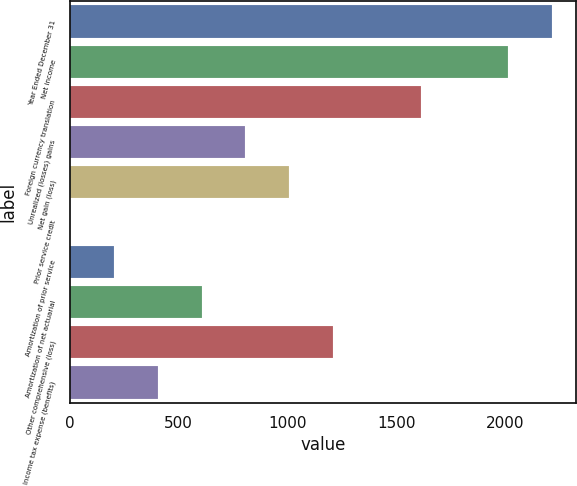Convert chart to OTSL. <chart><loc_0><loc_0><loc_500><loc_500><bar_chart><fcel>Year Ended December 31<fcel>Net income<fcel>Foreign currency translation<fcel>Unrealized (losses) gains<fcel>Net gain (loss)<fcel>Prior service credit<fcel>Amortization of prior service<fcel>Amortization of net actuarial<fcel>Other comprehensive (loss)<fcel>Income tax expense (benefits)<nl><fcel>2216.4<fcel>2015<fcel>1612.2<fcel>806.6<fcel>1008<fcel>1<fcel>202.4<fcel>605.2<fcel>1209.4<fcel>403.8<nl></chart> 